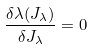Convert formula to latex. <formula><loc_0><loc_0><loc_500><loc_500>\frac { \delta \lambda ( J _ { \lambda } ) } { \delta J _ { \lambda } } = 0</formula> 